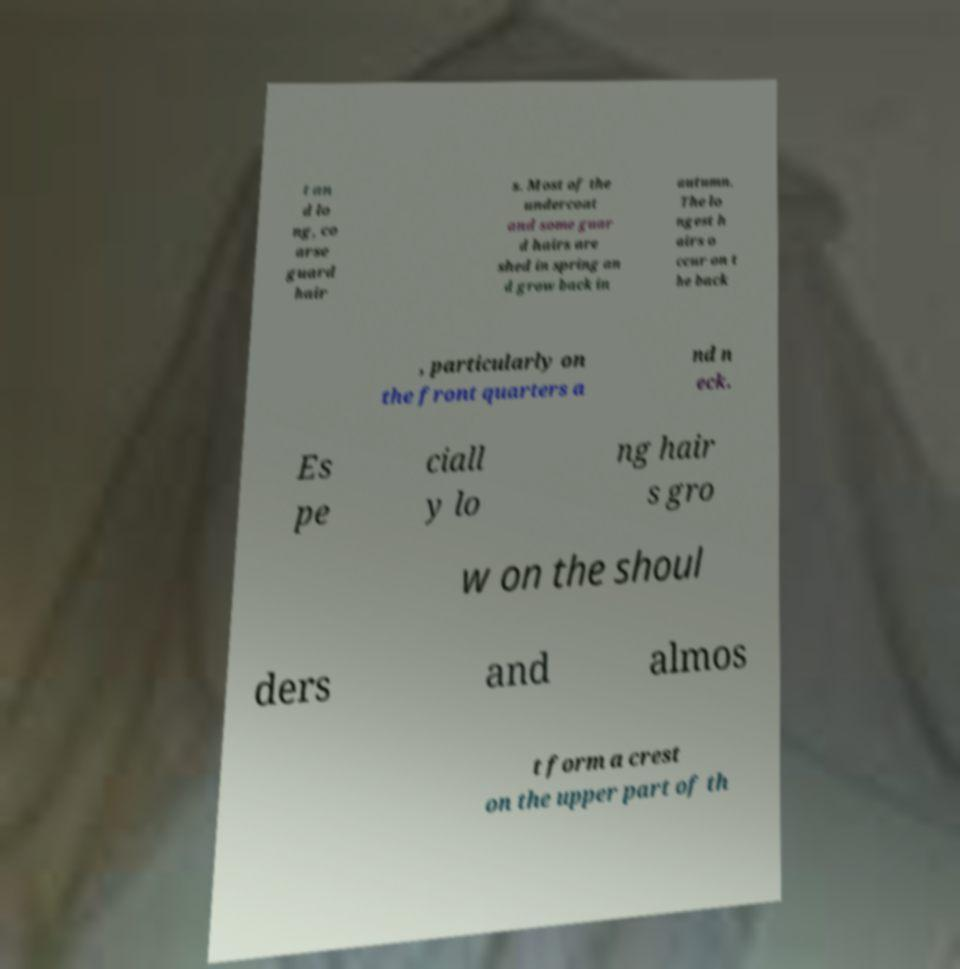Could you assist in decoding the text presented in this image and type it out clearly? t an d lo ng, co arse guard hair s. Most of the undercoat and some guar d hairs are shed in spring an d grow back in autumn. The lo ngest h airs o ccur on t he back , particularly on the front quarters a nd n eck. Es pe ciall y lo ng hair s gro w on the shoul ders and almos t form a crest on the upper part of th 